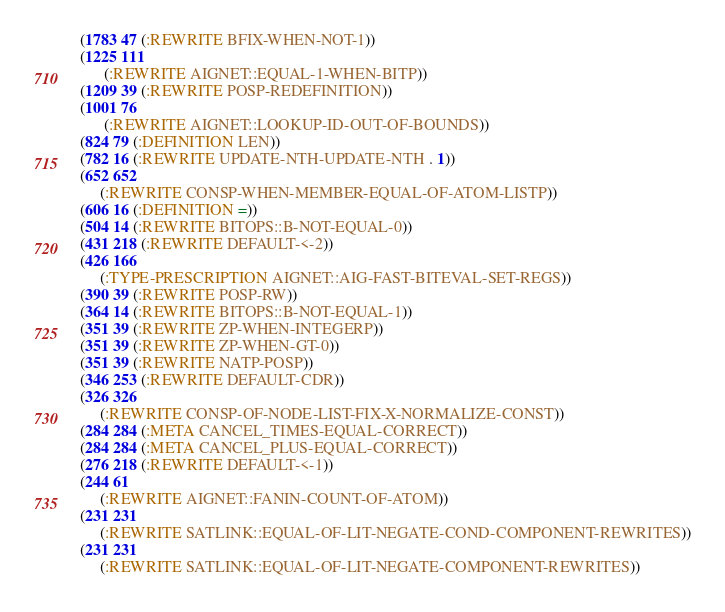<code> <loc_0><loc_0><loc_500><loc_500><_Lisp_> (1783 47 (:REWRITE BFIX-WHEN-NOT-1))
 (1225 111
       (:REWRITE AIGNET::EQUAL-1-WHEN-BITP))
 (1209 39 (:REWRITE POSP-REDEFINITION))
 (1001 76
       (:REWRITE AIGNET::LOOKUP-ID-OUT-OF-BOUNDS))
 (824 79 (:DEFINITION LEN))
 (782 16 (:REWRITE UPDATE-NTH-UPDATE-NTH . 1))
 (652 652
      (:REWRITE CONSP-WHEN-MEMBER-EQUAL-OF-ATOM-LISTP))
 (606 16 (:DEFINITION =))
 (504 14 (:REWRITE BITOPS::B-NOT-EQUAL-0))
 (431 218 (:REWRITE DEFAULT-<-2))
 (426 166
      (:TYPE-PRESCRIPTION AIGNET::AIG-FAST-BITEVAL-SET-REGS))
 (390 39 (:REWRITE POSP-RW))
 (364 14 (:REWRITE BITOPS::B-NOT-EQUAL-1))
 (351 39 (:REWRITE ZP-WHEN-INTEGERP))
 (351 39 (:REWRITE ZP-WHEN-GT-0))
 (351 39 (:REWRITE NATP-POSP))
 (346 253 (:REWRITE DEFAULT-CDR))
 (326 326
      (:REWRITE CONSP-OF-NODE-LIST-FIX-X-NORMALIZE-CONST))
 (284 284 (:META CANCEL_TIMES-EQUAL-CORRECT))
 (284 284 (:META CANCEL_PLUS-EQUAL-CORRECT))
 (276 218 (:REWRITE DEFAULT-<-1))
 (244 61
      (:REWRITE AIGNET::FANIN-COUNT-OF-ATOM))
 (231 231
      (:REWRITE SATLINK::EQUAL-OF-LIT-NEGATE-COND-COMPONENT-REWRITES))
 (231 231
      (:REWRITE SATLINK::EQUAL-OF-LIT-NEGATE-COMPONENT-REWRITES))</code> 